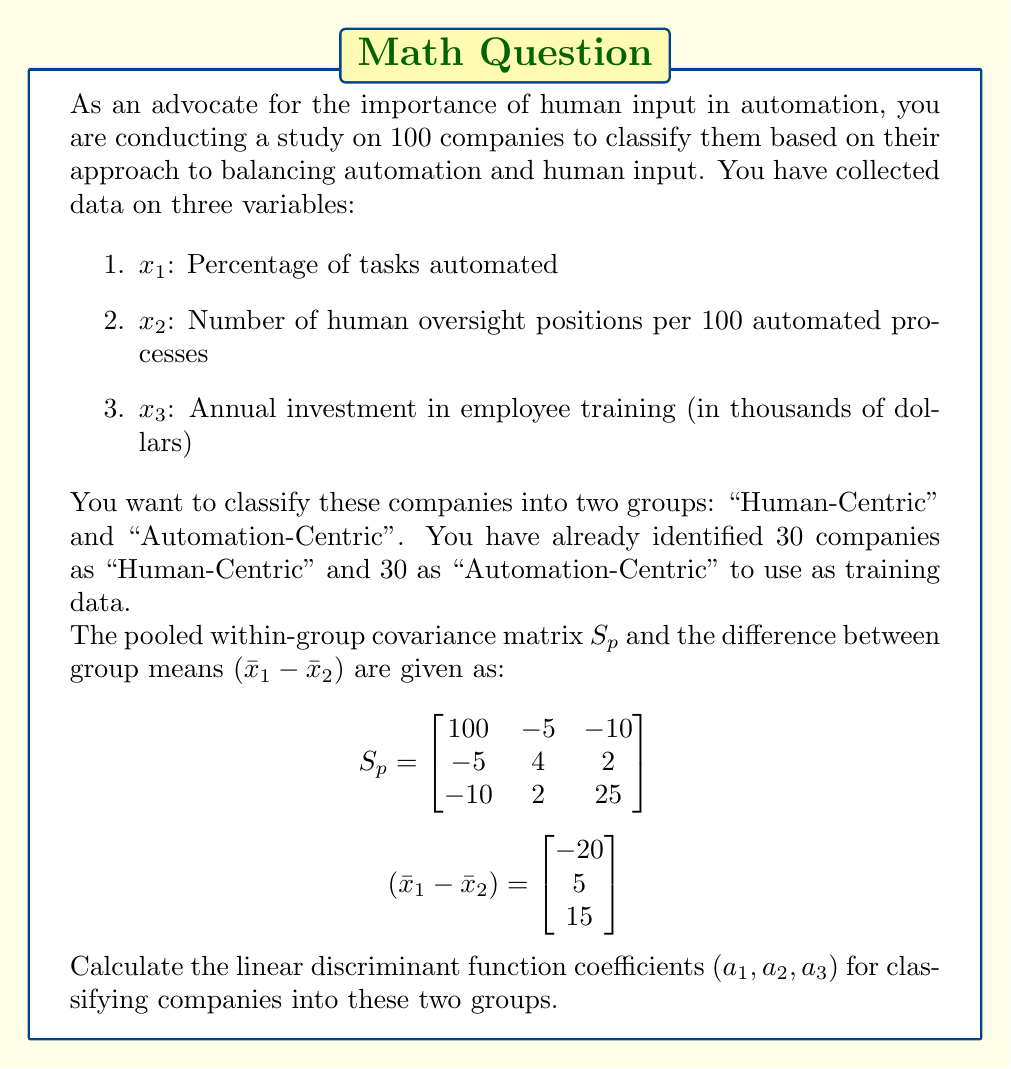Help me with this question. To solve this problem, we need to use the linear discriminant analysis (LDA) formula. The linear discriminant function coefficients are calculated using the following equation:

$$\mathbf{a} = S_p^{-1}(\bar{x}_1 - \bar{x}_2)$$

Where:
- $\mathbf{a}$ is the vector of discriminant function coefficients
- $S_p^{-1}$ is the inverse of the pooled within-group covariance matrix
- $(\bar{x}_1 - \bar{x}_2)$ is the difference between group means

Steps to solve:

1. First, we need to find the inverse of $S_p$. We can use matrix inversion techniques or a calculator for this step. The inverse of $S_p$ is:

$$S_p^{-1} = \begin{bmatrix}
0.0104 & 0.0135 & 0.0047 \\
0.0135 & 0.2627 & -0.0089 \\
0.0047 & -0.0089 & 0.0417
\end{bmatrix}$$

2. Now, we multiply $S_p^{-1}$ by $(\bar{x}_1 - \bar{x}_2)$:

$$\mathbf{a} = \begin{bmatrix}
0.0104 & 0.0135 & 0.0047 \\
0.0135 & 0.2627 & -0.0089 \\
0.0047 & -0.0089 & 0.0417
\end{bmatrix} \times \begin{bmatrix}
-20 \\
5 \\
15
\end{bmatrix}$$

3. Performing the matrix multiplication:

$$\mathbf{a} = \begin{bmatrix}
(-20 \times 0.0104) + (5 \times 0.0135) + (15 \times 0.0047) \\
(-20 \times 0.0135) + (5 \times 0.2627) + (15 \times -0.0089) \\
(-20 \times 0.0047) + (5 \times -0.0089) + (15 \times 0.0417)
\end{bmatrix}$$

4. Calculating the final values:

$$\mathbf{a} = \begin{bmatrix}
-0.1285 \\
1.1780 \\
0.5335
\end{bmatrix}$$

Therefore, the linear discriminant function coefficients are:
$a_1 = -0.1285$, $a_2 = 1.1780$, and $a_3 = 0.5335$.
Answer: The linear discriminant function coefficients are:
$a_1 = -0.1285$
$a_2 = 1.1780$
$a_3 = 0.5335$ 